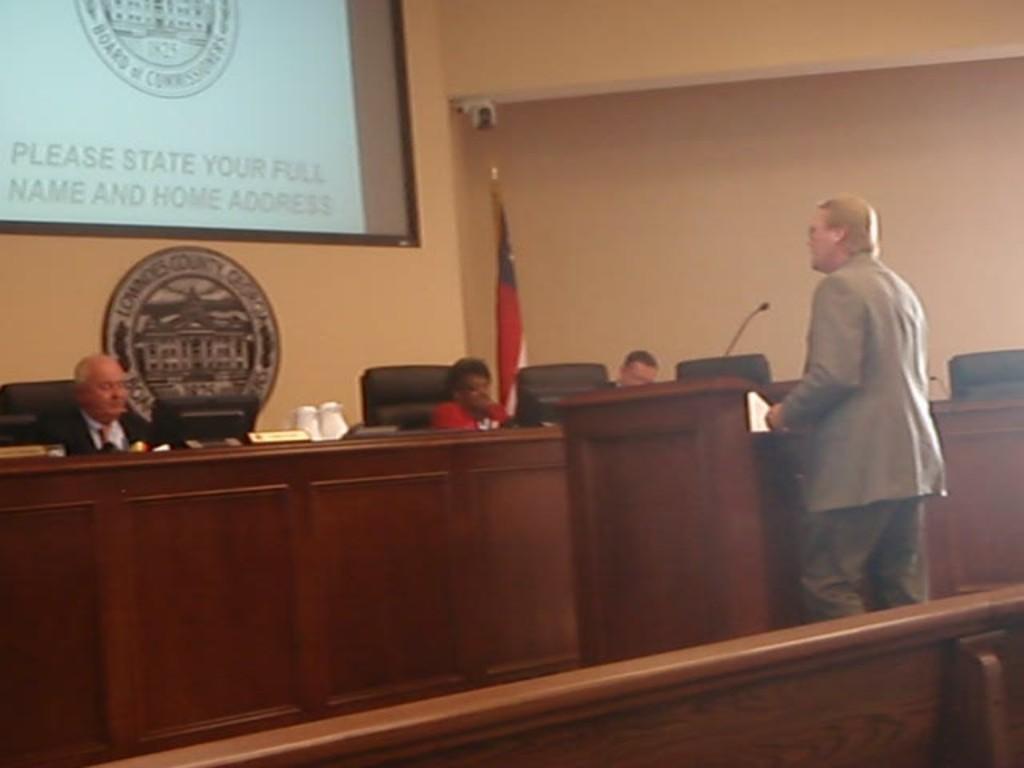In one or two sentences, can you explain what this image depicts? In this picture we can see four people, three are seated on the chair and one person is standing, in front of the seated people we can find a name board, monitor and a microphone on the table, in the background we can see a projector screen, a flag and a wall. 